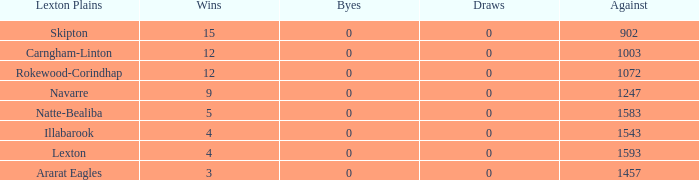What team has fewer than 9 wins and less than 1593 against? Natte-Bealiba, Illabarook, Ararat Eagles. 